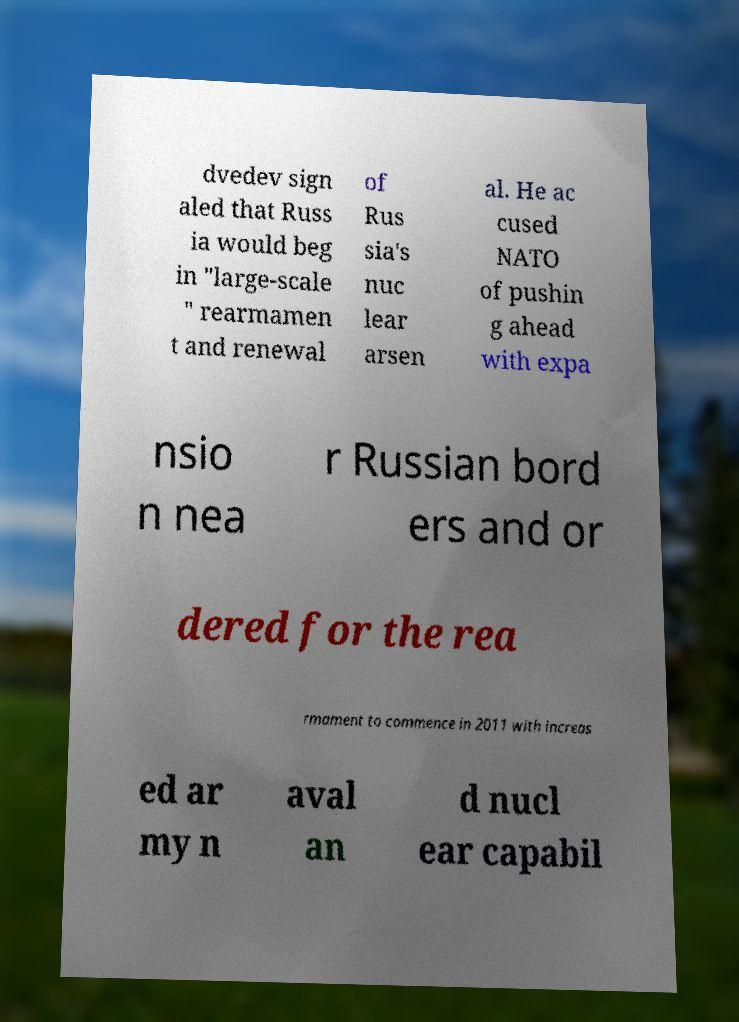What messages or text are displayed in this image? I need them in a readable, typed format. dvedev sign aled that Russ ia would beg in "large-scale " rearmamen t and renewal of Rus sia's nuc lear arsen al. He ac cused NATO of pushin g ahead with expa nsio n nea r Russian bord ers and or dered for the rea rmament to commence in 2011 with increas ed ar my n aval an d nucl ear capabil 